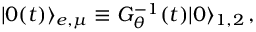Convert formula to latex. <formula><loc_0><loc_0><loc_500><loc_500>| 0 ( t ) \rangle _ { e , \mu } \equiv G _ { \theta } ^ { - 1 } ( t ) | 0 \rangle _ { 1 , 2 } \, ,</formula> 